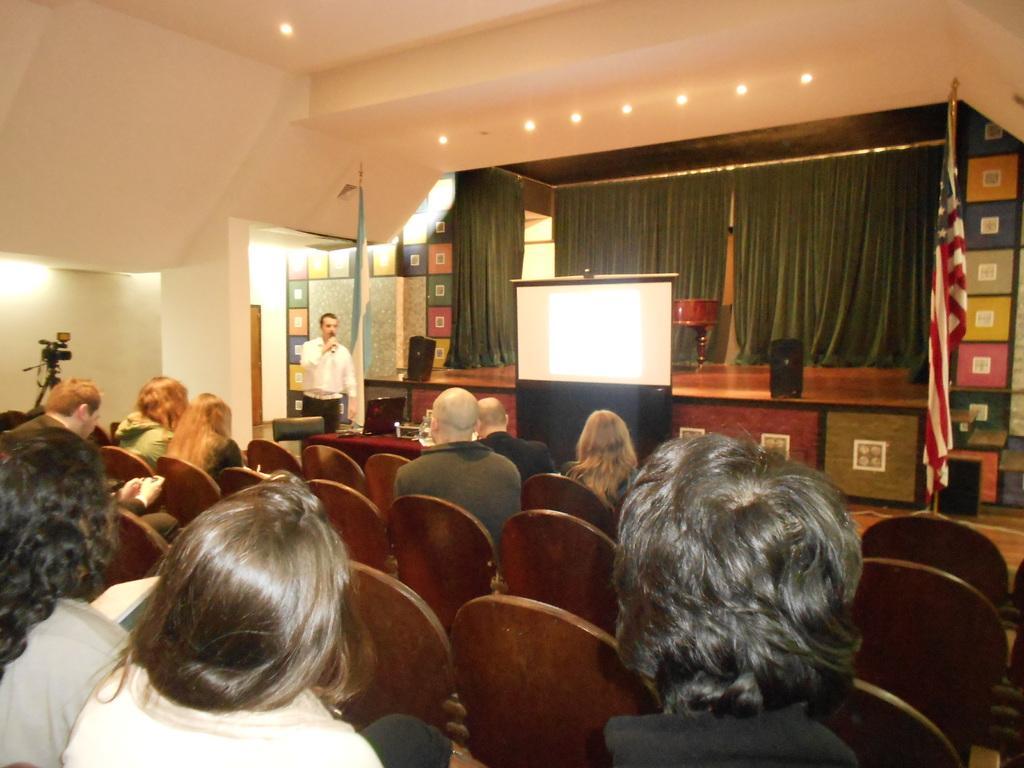Please provide a concise description of this image. Most of the persons are sitting on a red chair. Far there is a stage, in-front of this stage there is a screen. On this stage there are speakers. This person is standing and speaking in-front of mic. Background of this man there is a flag. On top there are lights. On this table there is a laptop and things. Far there is a camera with stand. 